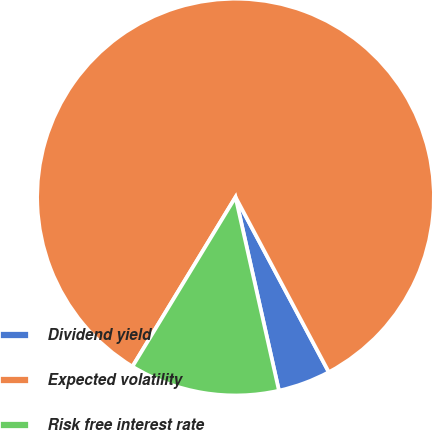<chart> <loc_0><loc_0><loc_500><loc_500><pie_chart><fcel>Dividend yield<fcel>Expected volatility<fcel>Risk free interest rate<nl><fcel>4.28%<fcel>83.51%<fcel>12.21%<nl></chart> 